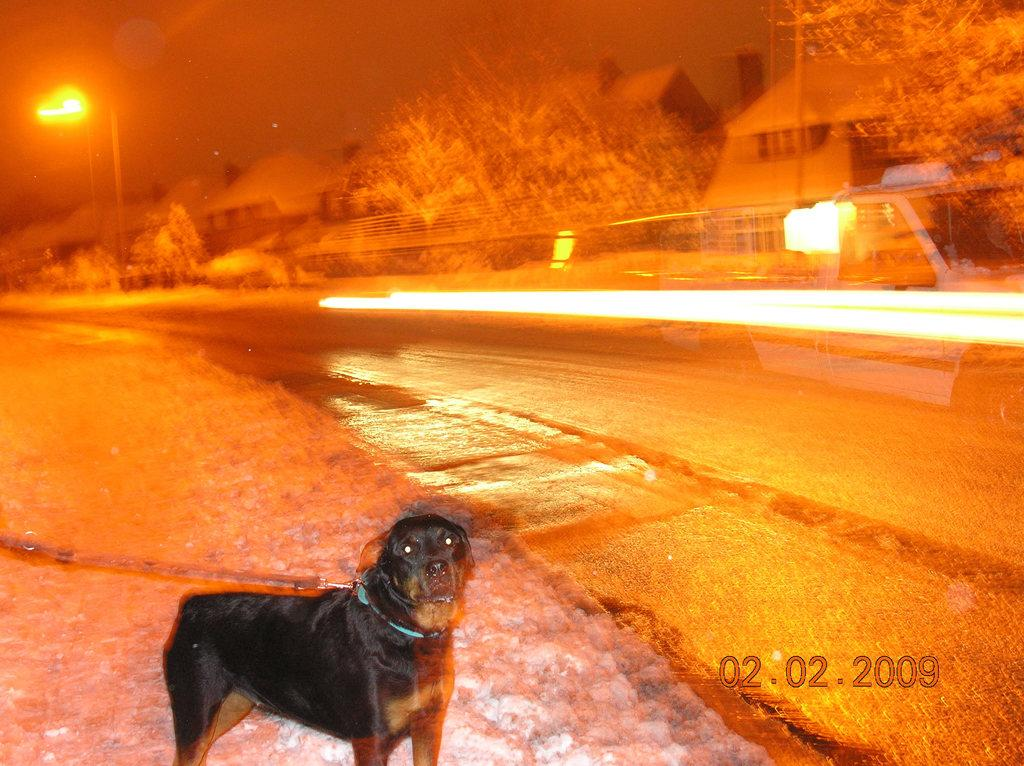What type of animal is in the image? There is a black dog in the image. What is the dog wearing? The dog is wearing a belt. What can be seen to the right of the image? There is a road to the right of the image. What is visible in the background of the image? There are trees, houses, poles, and the sky visible in the background of the image. What historical event is the dog commemorating in the image? There is no indication of a historical event in the image; it simply features a black dog wearing a belt. 